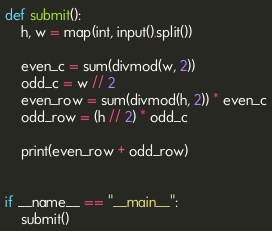Convert code to text. <code><loc_0><loc_0><loc_500><loc_500><_Python_>
def submit():
    h, w = map(int, input().split())
    
    even_c = sum(divmod(w, 2))
    odd_c = w // 2
    even_row = sum(divmod(h, 2)) * even_c
    odd_row = (h // 2) * odd_c

    print(even_row + odd_row)


if __name__ == "__main__":
    submit()</code> 